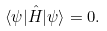<formula> <loc_0><loc_0><loc_500><loc_500>\langle \psi | \hat { H } | \psi \rangle = 0 .</formula> 